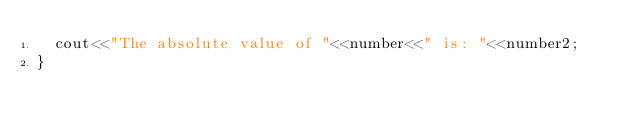Convert code to text. <code><loc_0><loc_0><loc_500><loc_500><_C++_>	cout<<"The absolute value of "<<number<<" is: "<<number2;
}
</code> 